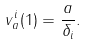<formula> <loc_0><loc_0><loc_500><loc_500>v _ { a } ^ { i } ( 1 ) = \frac { a } { \delta _ { i } } .</formula> 